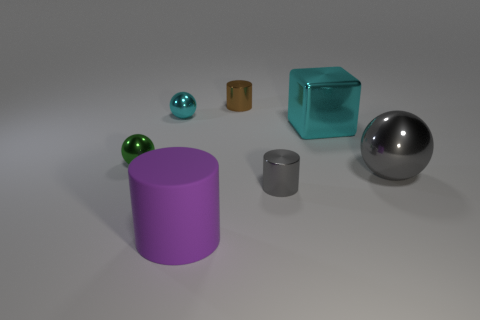Is there anything else that is the same material as the big purple thing?
Keep it short and to the point. No. What number of other objects are the same size as the purple thing?
Your answer should be compact. 2. Does the big cyan object have the same material as the purple cylinder?
Offer a terse response. No. The small cylinder that is in front of the cyan metal thing to the left of the small brown shiny cylinder is what color?
Ensure brevity in your answer.  Gray. There is another rubber thing that is the same shape as the tiny brown object; what size is it?
Your answer should be compact. Large. What number of green metal things are right of the tiny cylinder to the left of the small shiny object that is in front of the large ball?
Your response must be concise. 0. Is the number of purple rubber cylinders greater than the number of tiny metallic cylinders?
Keep it short and to the point. No. How many gray things are there?
Make the answer very short. 2. What shape is the tiny thing that is in front of the green sphere behind the metal cylinder that is to the right of the small brown object?
Ensure brevity in your answer.  Cylinder. Are there fewer small cyan objects right of the large cyan metal block than tiny brown metallic cylinders on the left side of the green thing?
Your response must be concise. No. 